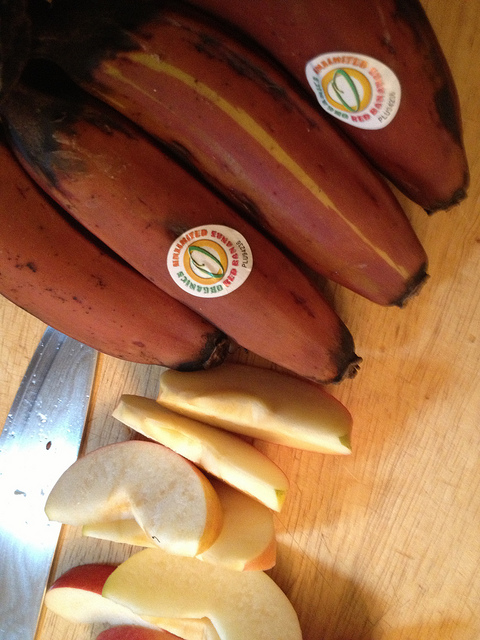<image>What brand bananas are they? I don't know what brand the bananas are. They can be organic, red bananas, or plantains. What brand bananas are they? I don't know the brand of the bananas. It can be red, regular, or organic. 